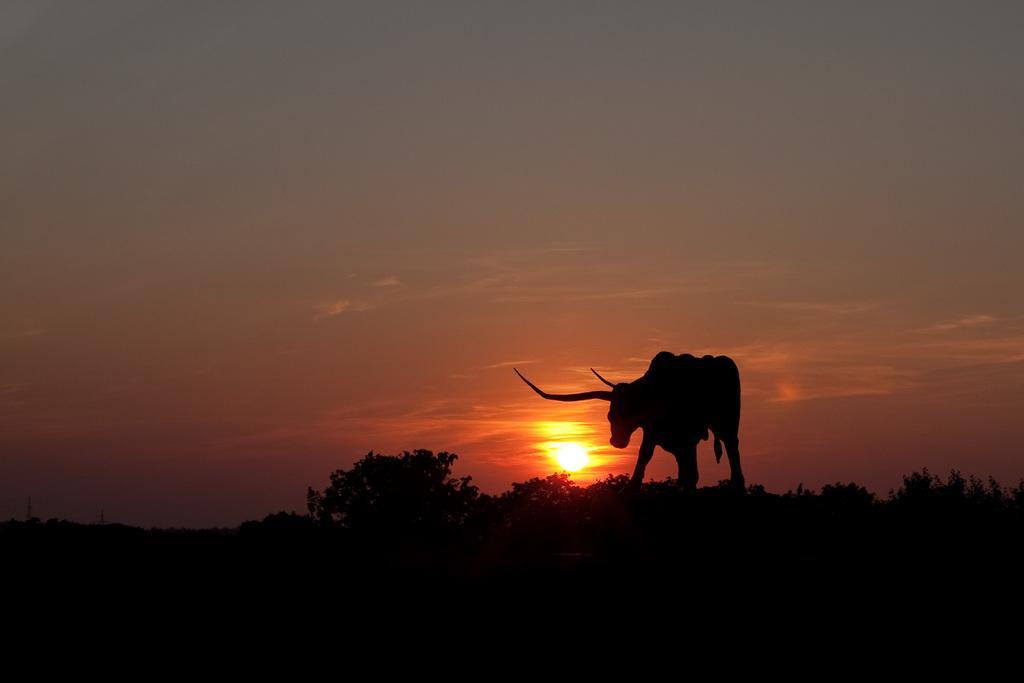In one or two sentences, can you explain what this image depicts? This picture is dark,we can see an animal on the surface and trees. In the background we can see sky. 